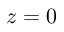Convert formula to latex. <formula><loc_0><loc_0><loc_500><loc_500>z = 0</formula> 